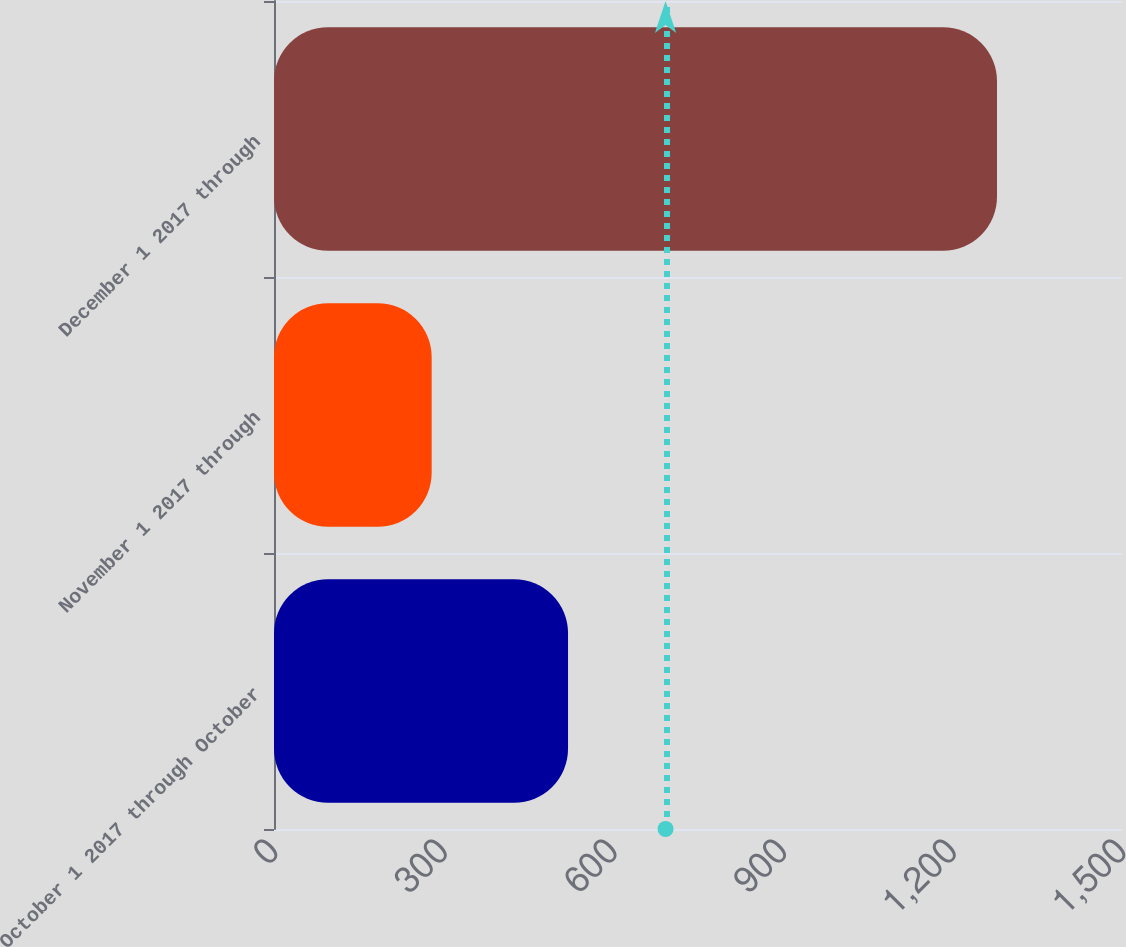<chart> <loc_0><loc_0><loc_500><loc_500><bar_chart><fcel>October 1 2017 through October<fcel>November 1 2017 through<fcel>December 1 2017 through<nl><fcel>520.1<fcel>278.9<fcel>1278.9<nl></chart> 